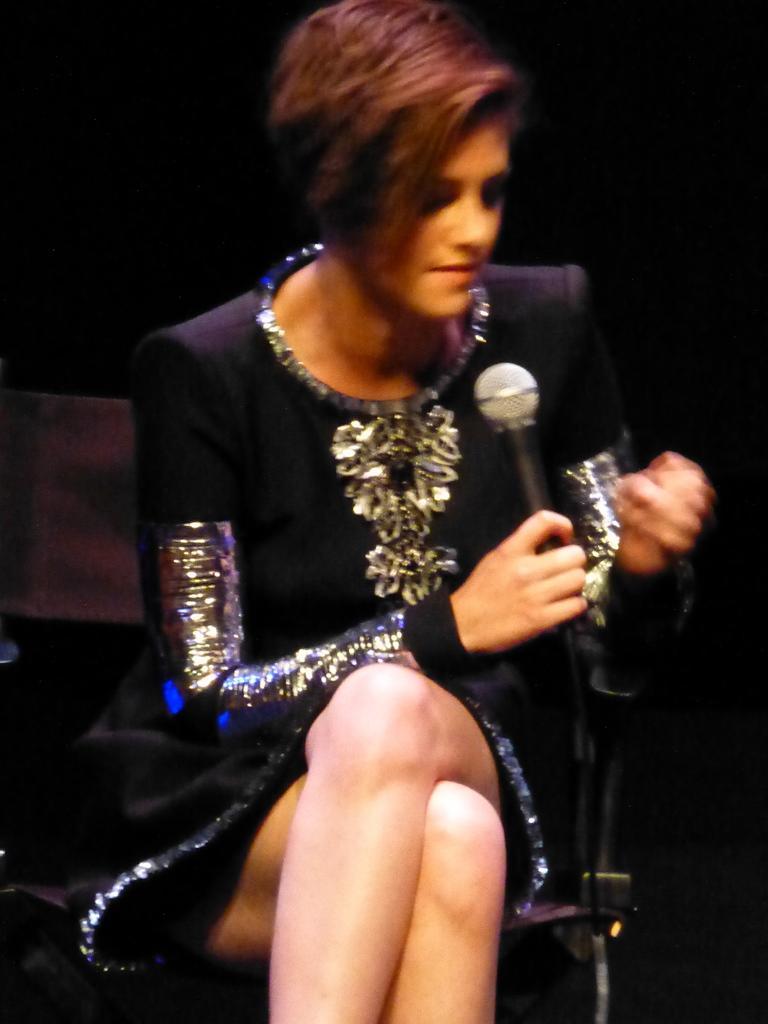In one or two sentences, can you explain what this image depicts? In this image I can see a woman is sitting on the chair. She is wearing black and silver dress. She is holding a mic. Background is in black color. 